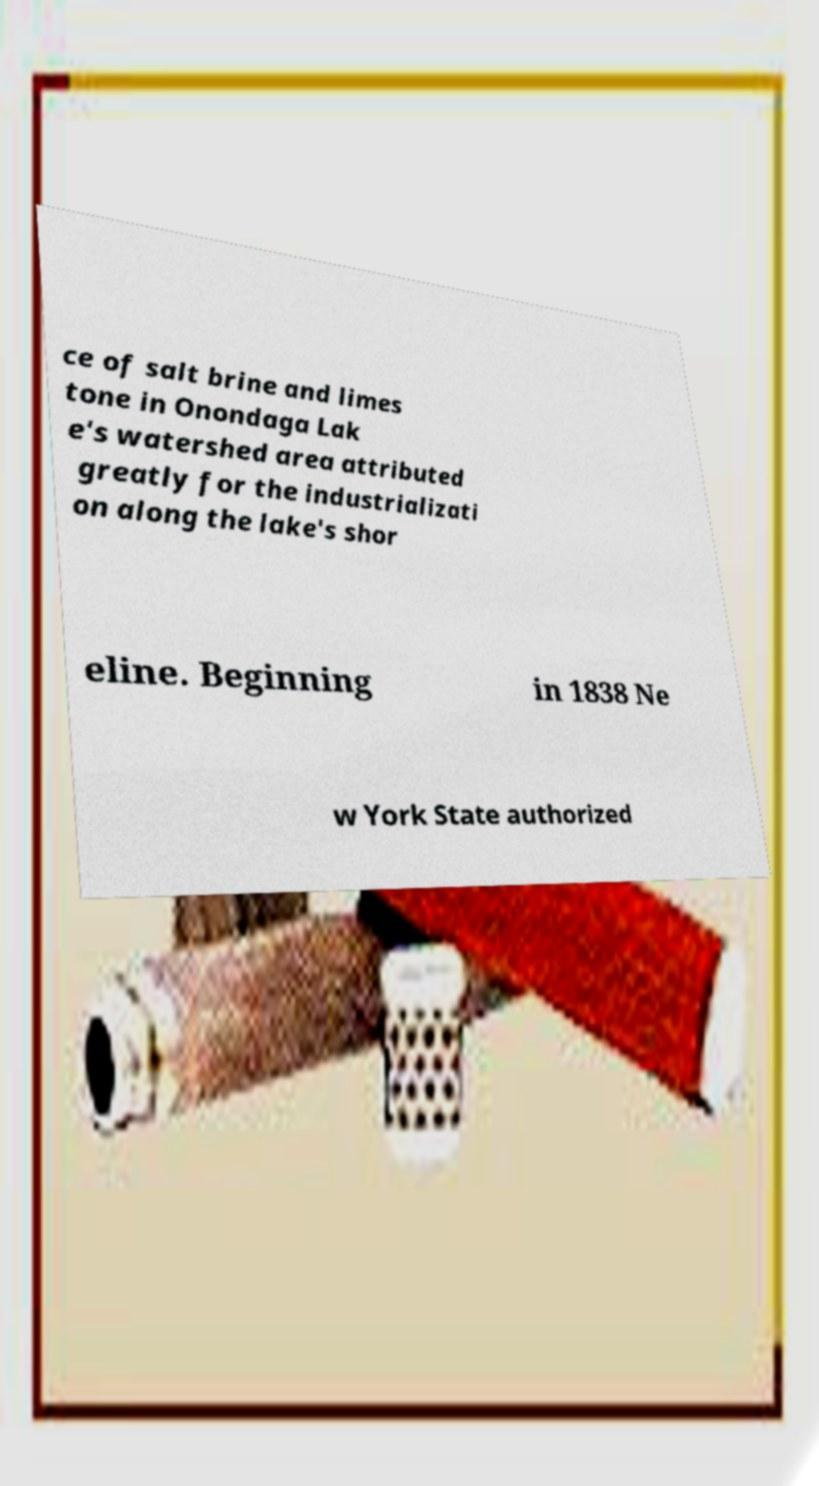I need the written content from this picture converted into text. Can you do that? ce of salt brine and limes tone in Onondaga Lak e's watershed area attributed greatly for the industrializati on along the lake's shor eline. Beginning in 1838 Ne w York State authorized 